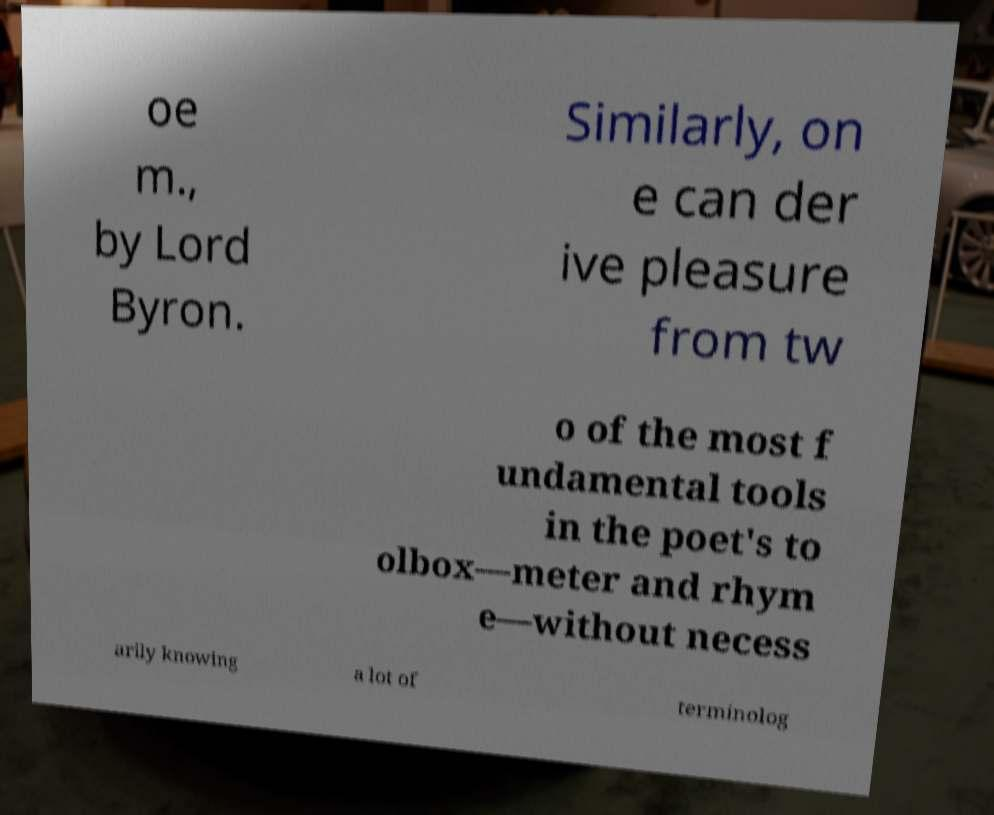I need the written content from this picture converted into text. Can you do that? oe m., by Lord Byron. Similarly, on e can der ive pleasure from tw o of the most f undamental tools in the poet's to olbox—meter and rhym e—without necess arily knowing a lot of terminolog 